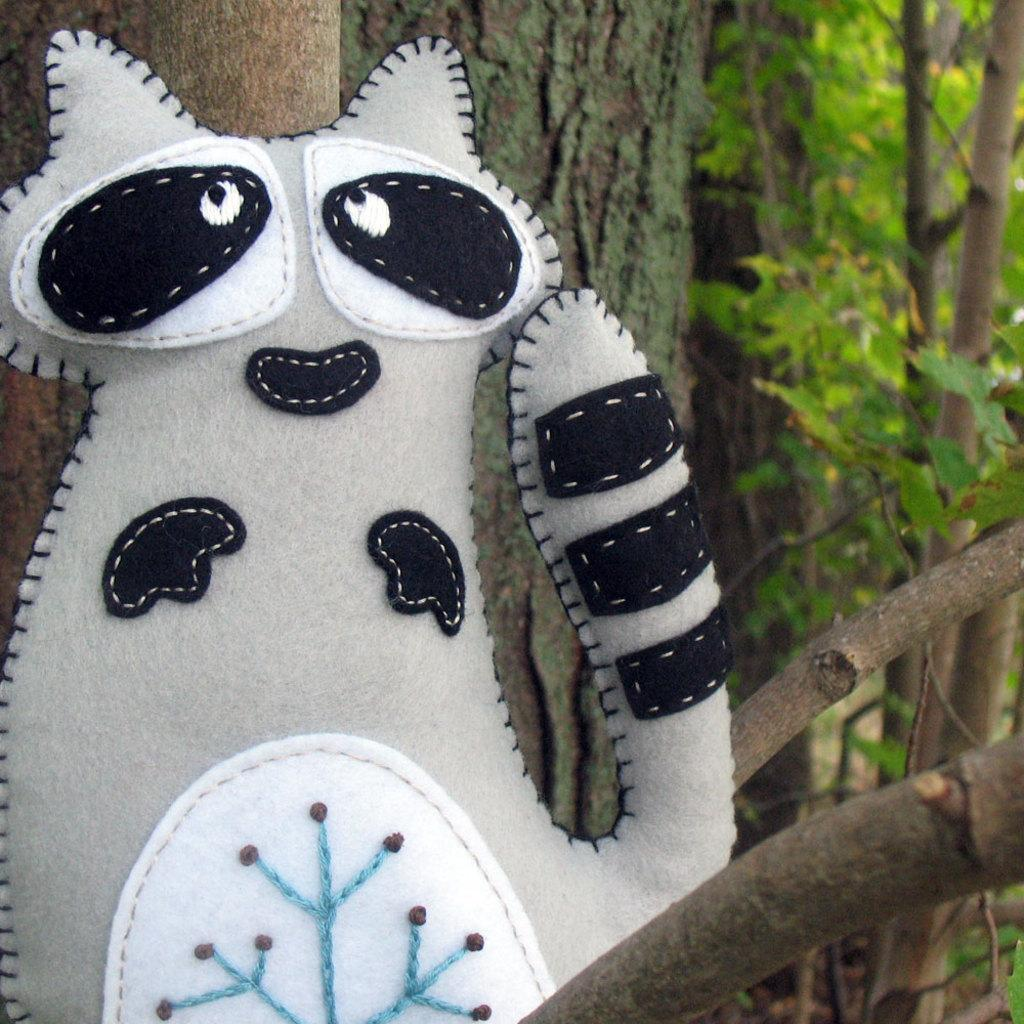What type of object is in the image? There is a doll in the image. What shape is the doll in? The doll is in the shape of a cat. What color is the doll? The doll is white in color. What can be seen on the right side of the image? There are trees on the right side of the image. Is there a frame around the doll in the image? There is no mention of a frame around the doll in the provided facts, so we cannot determine if one is present in the image. 